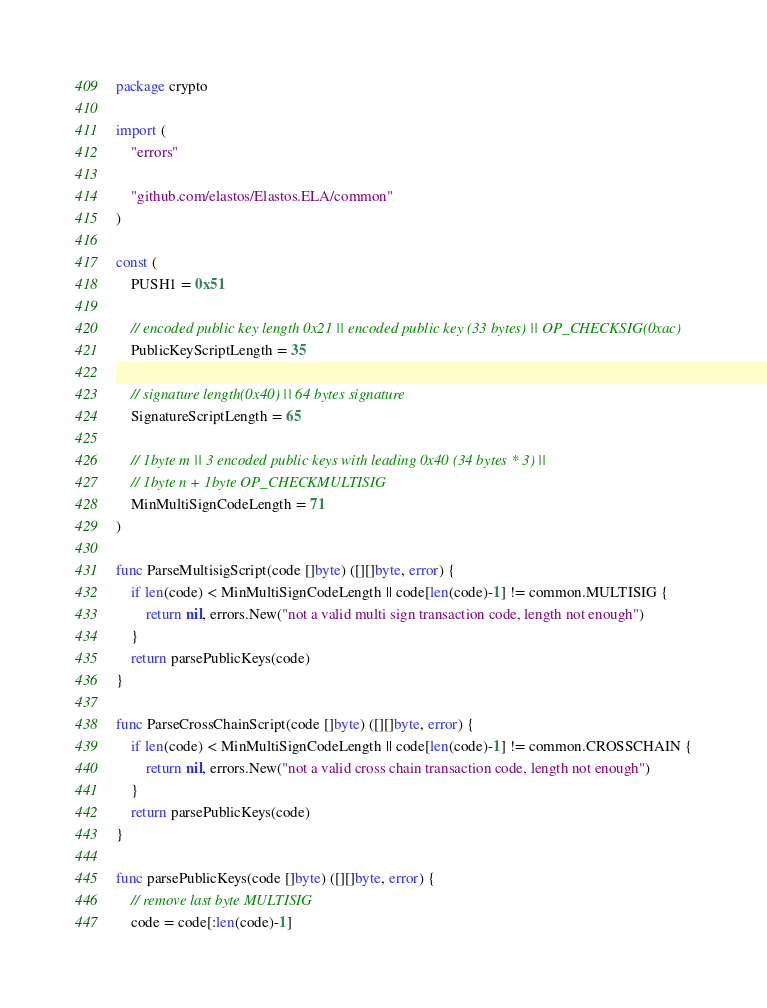Convert code to text. <code><loc_0><loc_0><loc_500><loc_500><_Go_>package crypto

import (
	"errors"

	"github.com/elastos/Elastos.ELA/common"
)

const (
	PUSH1 = 0x51

	// encoded public key length 0x21 || encoded public key (33 bytes) || OP_CHECKSIG(0xac)
	PublicKeyScriptLength = 35

	// signature length(0x40) || 64 bytes signature
	SignatureScriptLength = 65

	// 1byte m || 3 encoded public keys with leading 0x40 (34 bytes * 3) ||
	// 1byte n + 1byte OP_CHECKMULTISIG
	MinMultiSignCodeLength = 71
)

func ParseMultisigScript(code []byte) ([][]byte, error) {
	if len(code) < MinMultiSignCodeLength || code[len(code)-1] != common.MULTISIG {
		return nil, errors.New("not a valid multi sign transaction code, length not enough")
	}
	return parsePublicKeys(code)
}

func ParseCrossChainScript(code []byte) ([][]byte, error) {
	if len(code) < MinMultiSignCodeLength || code[len(code)-1] != common.CROSSCHAIN {
		return nil, errors.New("not a valid cross chain transaction code, length not enough")
	}
	return parsePublicKeys(code)
}

func parsePublicKeys(code []byte) ([][]byte, error) {
	// remove last byte MULTISIG
	code = code[:len(code)-1]</code> 